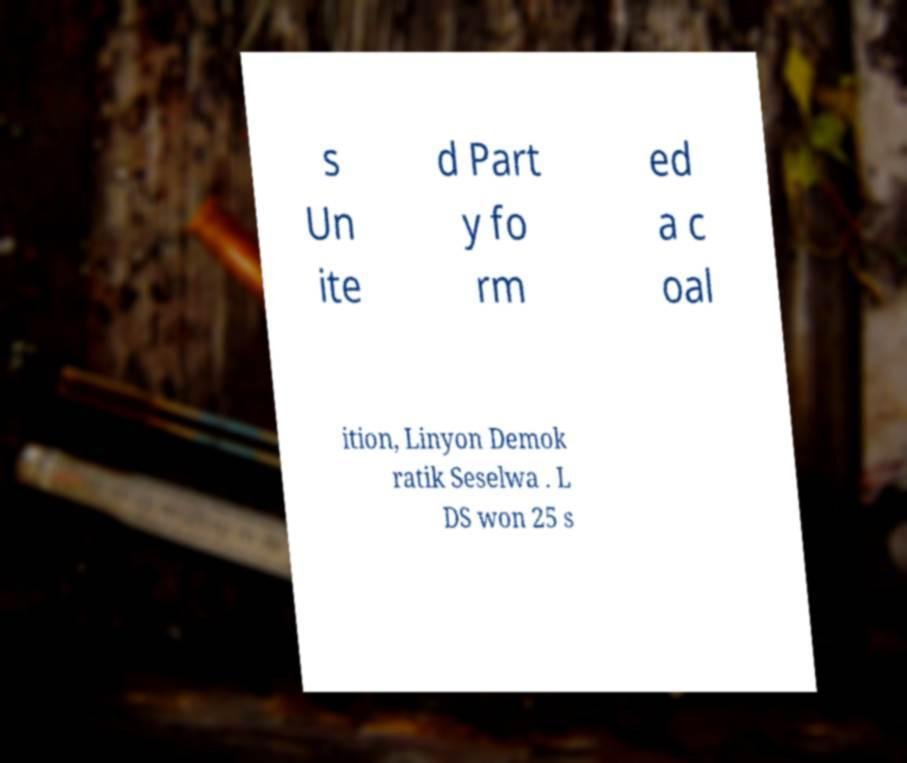There's text embedded in this image that I need extracted. Can you transcribe it verbatim? s Un ite d Part y fo rm ed a c oal ition, Linyon Demok ratik Seselwa . L DS won 25 s 